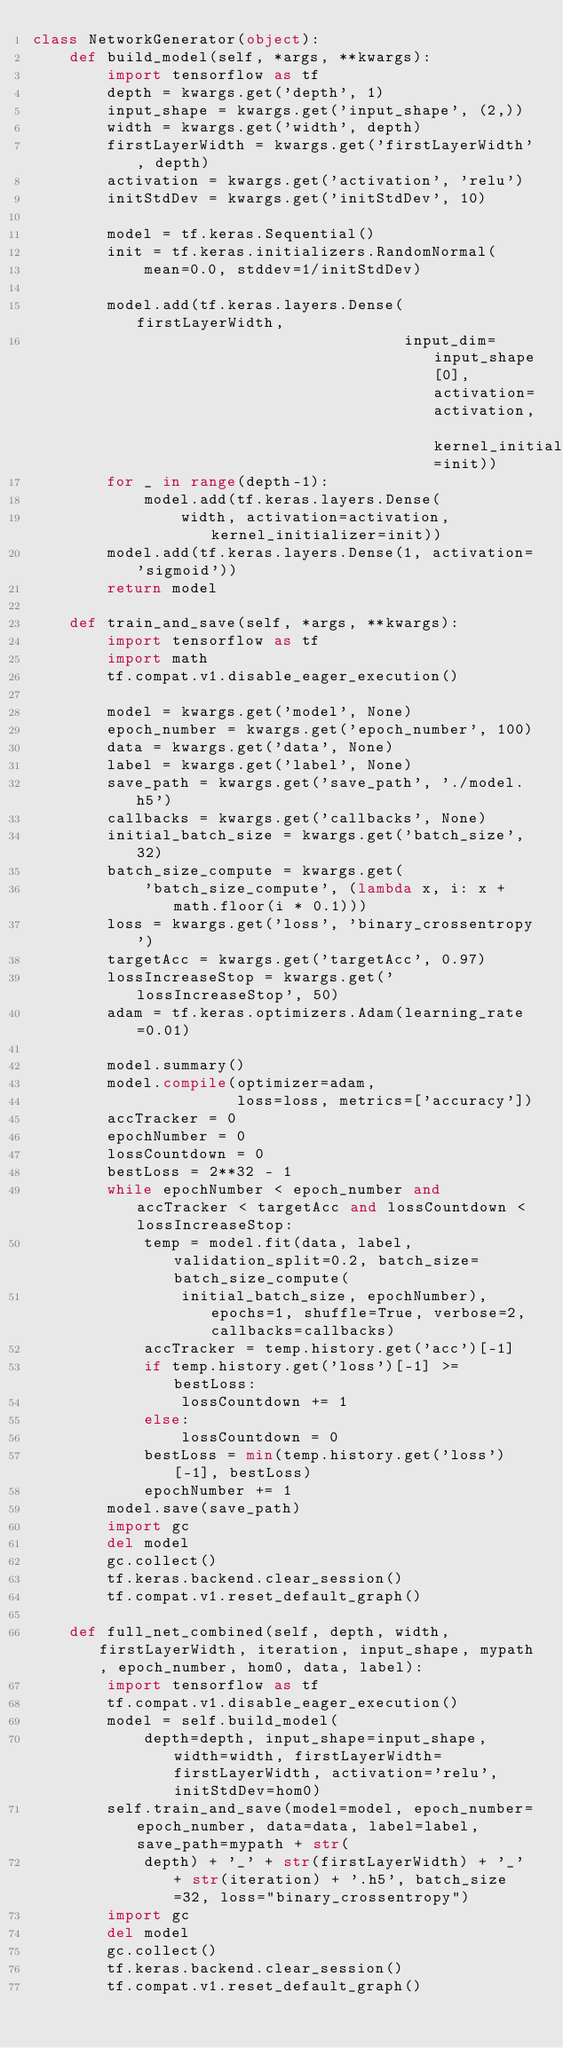<code> <loc_0><loc_0><loc_500><loc_500><_Python_>class NetworkGenerator(object):
    def build_model(self, *args, **kwargs):
        import tensorflow as tf
        depth = kwargs.get('depth', 1)
        input_shape = kwargs.get('input_shape', (2,))
        width = kwargs.get('width', depth)
        firstLayerWidth = kwargs.get('firstLayerWidth', depth)
        activation = kwargs.get('activation', 'relu')
        initStdDev = kwargs.get('initStdDev', 10)

        model = tf.keras.Sequential()
        init = tf.keras.initializers.RandomNormal(
            mean=0.0, stddev=1/initStdDev)

        model.add(tf.keras.layers.Dense(firstLayerWidth,
                                        input_dim=input_shape[0], activation=activation, kernel_initializer=init))
        for _ in range(depth-1):
            model.add(tf.keras.layers.Dense(
                width, activation=activation, kernel_initializer=init))
        model.add(tf.keras.layers.Dense(1, activation='sigmoid'))
        return model

    def train_and_save(self, *args, **kwargs):
        import tensorflow as tf
        import math
        tf.compat.v1.disable_eager_execution()

        model = kwargs.get('model', None)
        epoch_number = kwargs.get('epoch_number', 100)
        data = kwargs.get('data', None)
        label = kwargs.get('label', None)
        save_path = kwargs.get('save_path', './model.h5')
        callbacks = kwargs.get('callbacks', None)
        initial_batch_size = kwargs.get('batch_size', 32)
        batch_size_compute = kwargs.get(
            'batch_size_compute', (lambda x, i: x + math.floor(i * 0.1)))
        loss = kwargs.get('loss', 'binary_crossentropy')
        targetAcc = kwargs.get('targetAcc', 0.97)
        lossIncreaseStop = kwargs.get('lossIncreaseStop', 50)
        adam = tf.keras.optimizers.Adam(learning_rate=0.01)

        model.summary()
        model.compile(optimizer=adam,
                      loss=loss, metrics=['accuracy'])
        accTracker = 0
        epochNumber = 0
        lossCountdown = 0
        bestLoss = 2**32 - 1
        while epochNumber < epoch_number and accTracker < targetAcc and lossCountdown < lossIncreaseStop:
            temp = model.fit(data, label, validation_split=0.2, batch_size=batch_size_compute(
                initial_batch_size, epochNumber), epochs=1, shuffle=True, verbose=2, callbacks=callbacks)
            accTracker = temp.history.get('acc')[-1]
            if temp.history.get('loss')[-1] >= bestLoss:
                lossCountdown += 1
            else:
                lossCountdown = 0
            bestLoss = min(temp.history.get('loss')[-1], bestLoss)
            epochNumber += 1
        model.save(save_path)
        import gc
        del model
        gc.collect()
        tf.keras.backend.clear_session()
        tf.compat.v1.reset_default_graph()

    def full_net_combined(self, depth, width, firstLayerWidth, iteration, input_shape, mypath, epoch_number, hom0, data, label):
        import tensorflow as tf
        tf.compat.v1.disable_eager_execution()
        model = self.build_model(
            depth=depth, input_shape=input_shape, width=width, firstLayerWidth=firstLayerWidth, activation='relu', initStdDev=hom0)
        self.train_and_save(model=model, epoch_number=epoch_number, data=data, label=label, save_path=mypath + str(
            depth) + '_' + str(firstLayerWidth) + '_' + str(iteration) + '.h5', batch_size=32, loss="binary_crossentropy")
        import gc
        del model
        gc.collect()
        tf.keras.backend.clear_session()
        tf.compat.v1.reset_default_graph()
</code> 